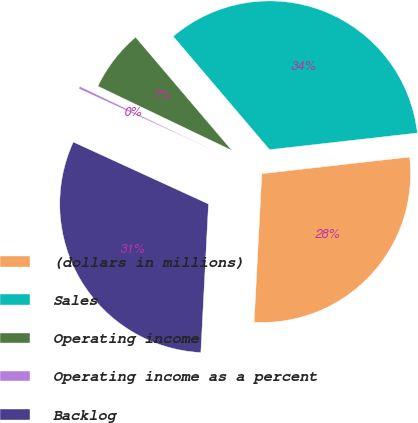Convert chart to OTSL. <chart><loc_0><loc_0><loc_500><loc_500><pie_chart><fcel>(dollars in millions)<fcel>Sales<fcel>Operating income<fcel>Operating income as a percent<fcel>Backlog<nl><fcel>27.61%<fcel>34.43%<fcel>6.67%<fcel>0.27%<fcel>31.02%<nl></chart> 